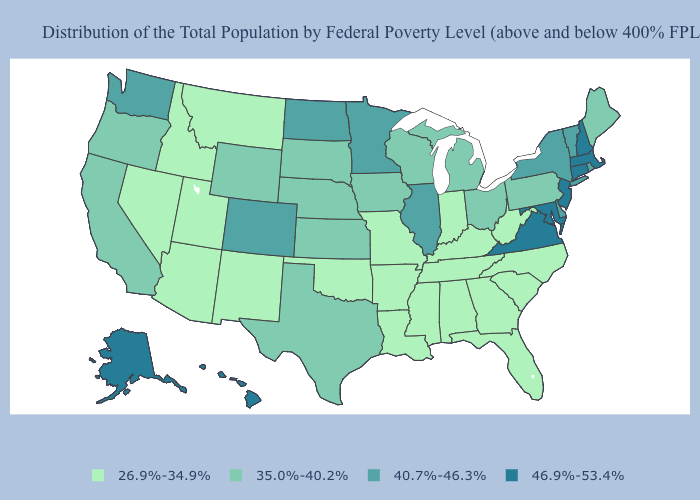Is the legend a continuous bar?
Short answer required. No. Does Texas have a higher value than Colorado?
Keep it brief. No. Name the states that have a value in the range 35.0%-40.2%?
Keep it brief. California, Iowa, Kansas, Maine, Michigan, Nebraska, Ohio, Oregon, Pennsylvania, South Dakota, Texas, Wisconsin, Wyoming. Among the states that border Delaware , which have the highest value?
Keep it brief. Maryland, New Jersey. What is the lowest value in the USA?
Be succinct. 26.9%-34.9%. What is the value of Maryland?
Short answer required. 46.9%-53.4%. Which states have the lowest value in the USA?
Concise answer only. Alabama, Arizona, Arkansas, Florida, Georgia, Idaho, Indiana, Kentucky, Louisiana, Mississippi, Missouri, Montana, Nevada, New Mexico, North Carolina, Oklahoma, South Carolina, Tennessee, Utah, West Virginia. Does Pennsylvania have the lowest value in the Northeast?
Be succinct. Yes. Name the states that have a value in the range 35.0%-40.2%?
Short answer required. California, Iowa, Kansas, Maine, Michigan, Nebraska, Ohio, Oregon, Pennsylvania, South Dakota, Texas, Wisconsin, Wyoming. What is the value of Hawaii?
Quick response, please. 46.9%-53.4%. Among the states that border Connecticut , which have the lowest value?
Keep it brief. New York, Rhode Island. Among the states that border California , does Nevada have the lowest value?
Write a very short answer. Yes. Does Arizona have the highest value in the West?
Quick response, please. No. Does Virginia have the lowest value in the South?
Short answer required. No. What is the highest value in the West ?
Short answer required. 46.9%-53.4%. 